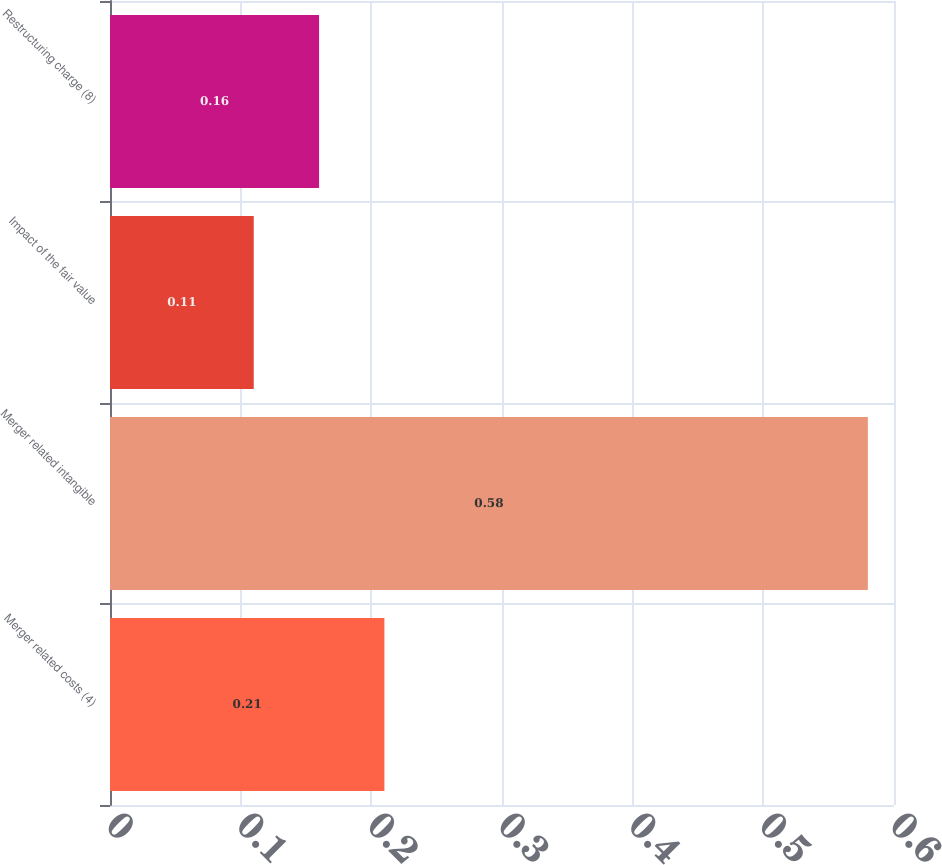<chart> <loc_0><loc_0><loc_500><loc_500><bar_chart><fcel>Merger related costs (4)<fcel>Merger related intangible<fcel>Impact of the fair value<fcel>Restructuring charge (8)<nl><fcel>0.21<fcel>0.58<fcel>0.11<fcel>0.16<nl></chart> 